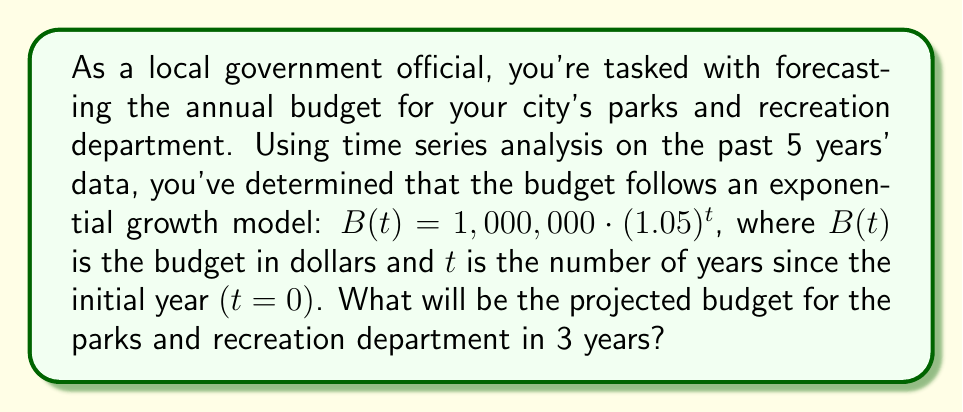Could you help me with this problem? To solve this problem, we'll follow these steps:

1) We're given the exponential growth model:
   $B(t) = 1,000,000 \cdot (1.05)^t$

2) We need to find the budget 3 years from now, so we'll substitute $t=3$ into our equation:
   $B(3) = 1,000,000 \cdot (1.05)^3$

3) Now, let's calculate this step-by-step:
   $B(3) = 1,000,000 \cdot (1.05)^3$
   $= 1,000,000 \cdot 1.157625$ (calculated by cubing 1.05)
   $= 1,157,625$

4) Rounding to the nearest dollar (as budgets are typically expressed in whole dollars):
   $B(3) \approx 1,157,625$

Therefore, the projected budget for the parks and recreation department in 3 years will be $1,157,625.
Answer: $1,157,625 